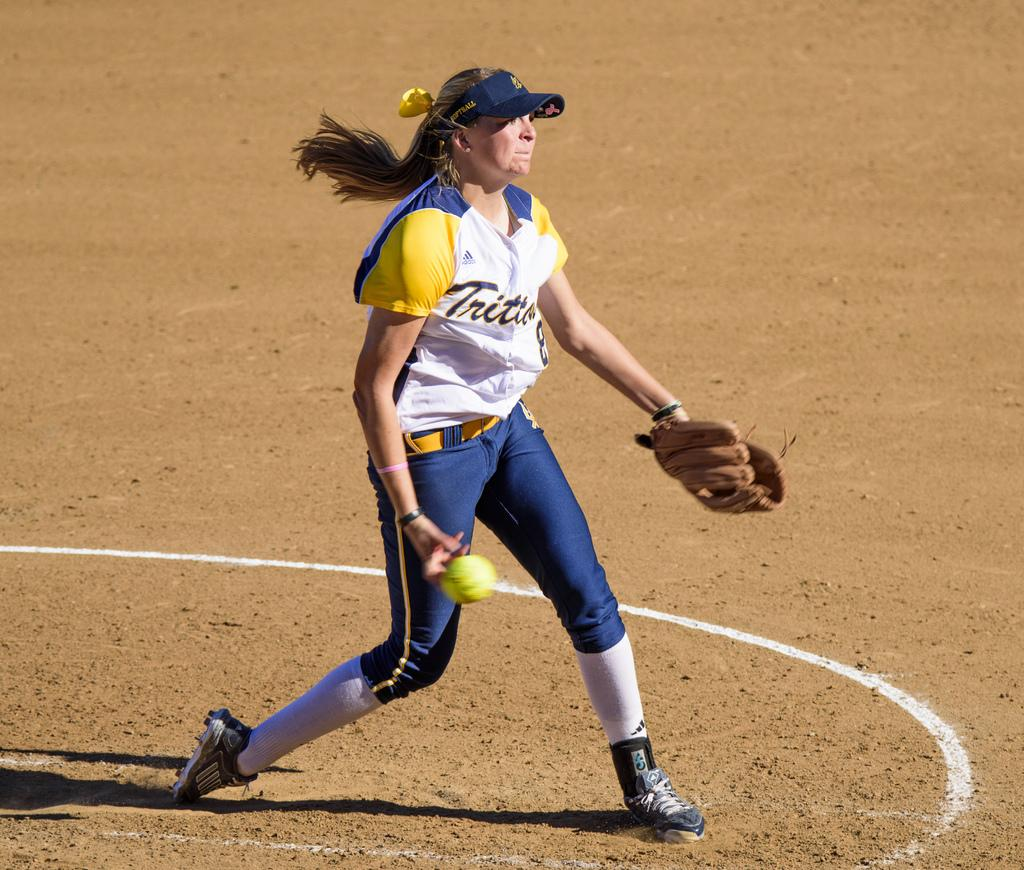Who is the main subject in the picture? There is a woman in the picture. What is the woman standing on? The woman is standing on the sand. What objects is the woman holding in her hands? The woman is holding a glove in one hand and a ball in her other hand. Is there any shade provided by an umbrella in the image? There is no mention of an umbrella or shade in the image. Is it raining in the image? There is no indication of rain in the image. 